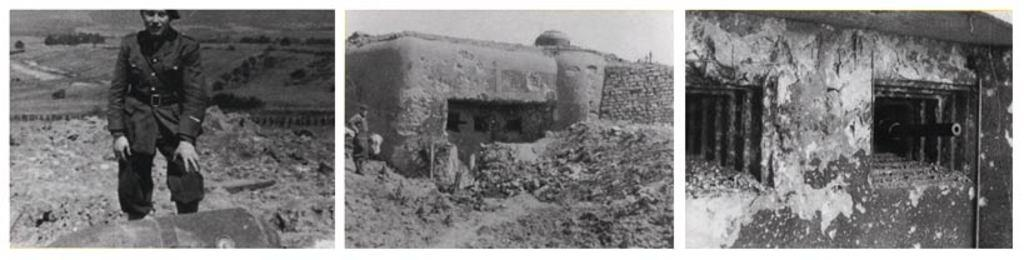Who or what can be seen in the image? There are people in the image. What type of structure is present in the image? There is a building in the image. What part of the natural environment is visible in the image? The sky and trees are visible in the image. What is the color scheme of the image? The image is black and white in color. How is the image composed? This is a collage picture. Can you see any toes in the image? There are no toes visible in the image. What type of bucket is used in the image? There is no bucket present in the image. 